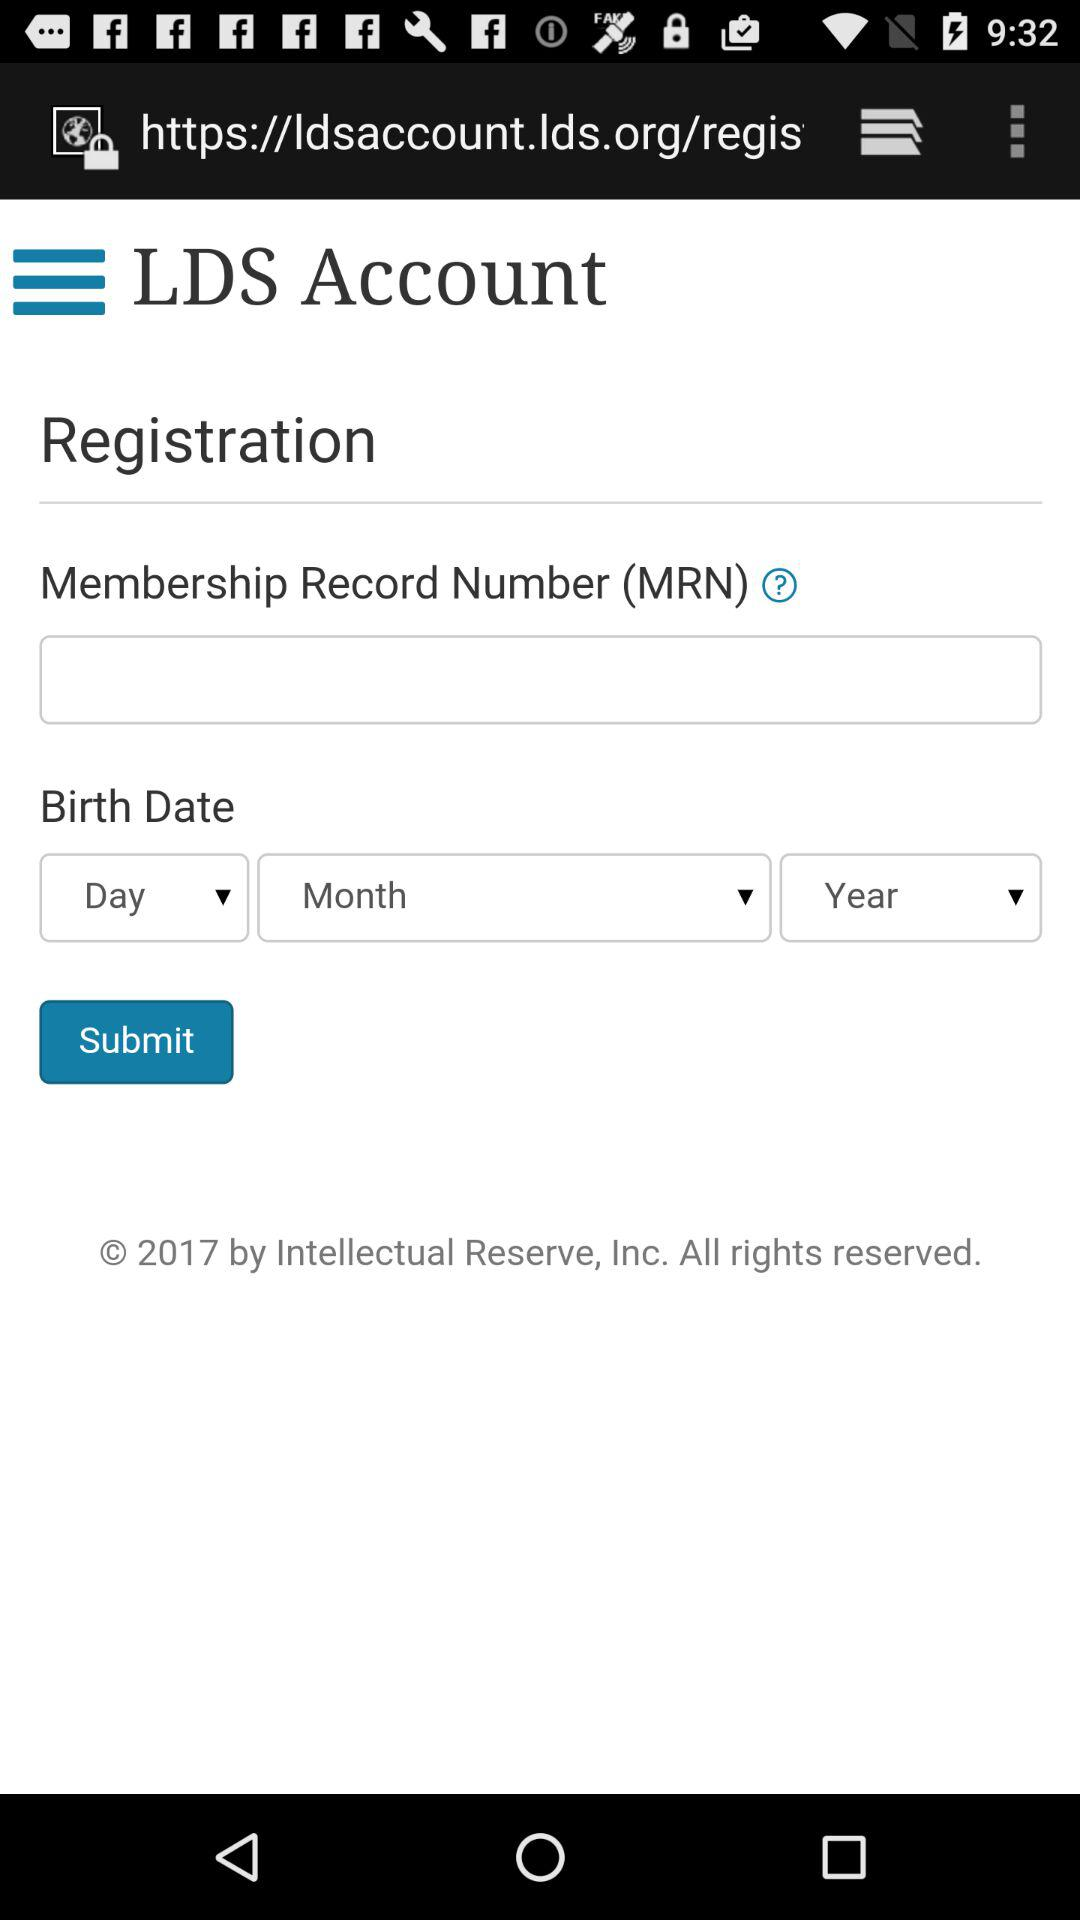What is the application name?
When the provided information is insufficient, respond with <no answer>. <no answer> 